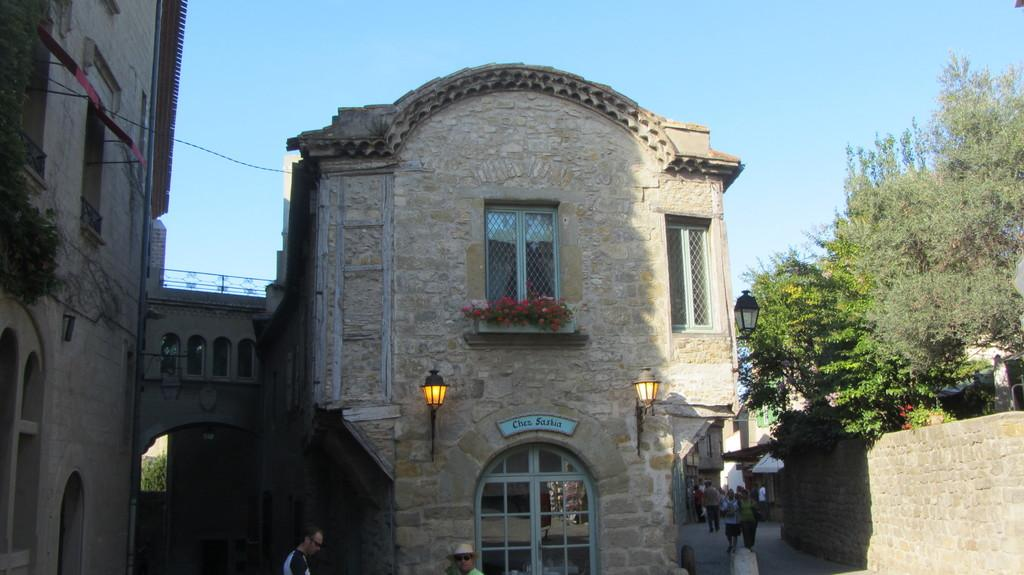What type of structures can be seen in the image? There are buildings in the image. What natural elements are present in the image? There are trees in the image. What can be seen illuminating the scene in the image? There are lights visible in the image. What are the people in the image doing? People are walking in the image. What is the color of the sky in the image? The sky is blue in the image. Can you see any polish on the people's shoes in the image? There is no information about the people's shoes or any polish on them in the image. Is there a lake visible in the image? There is no lake present in the image; it features buildings, trees, lights, people walking, and a blue sky. 